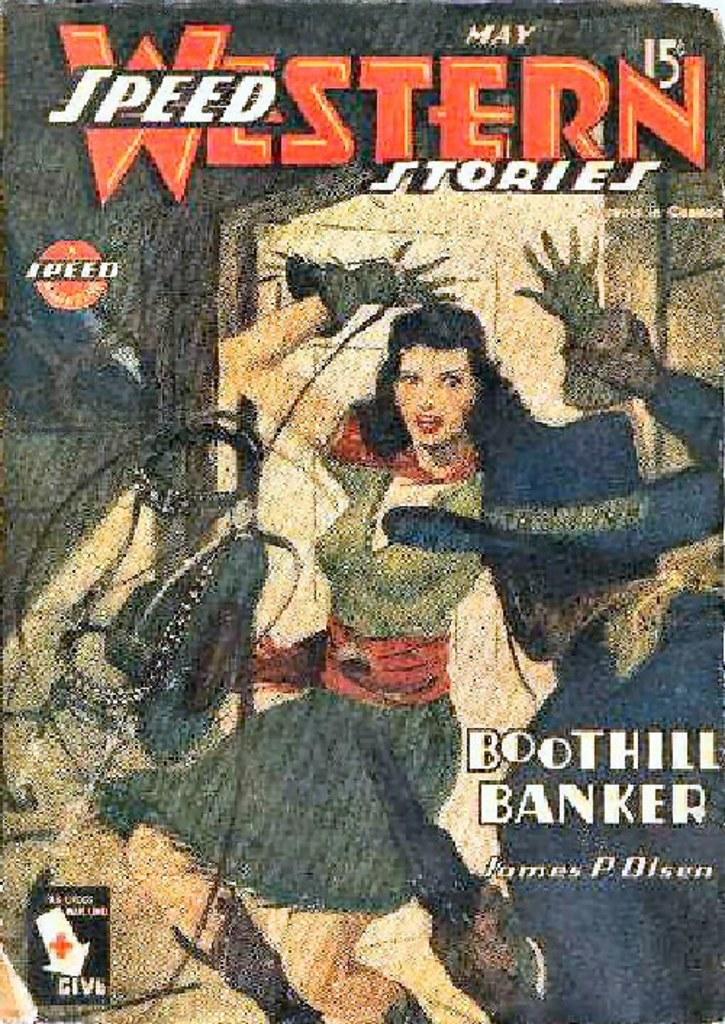What is the date on this game?
Offer a very short reply. May. What is the title of this book?
Offer a very short reply. Speed western stories. 